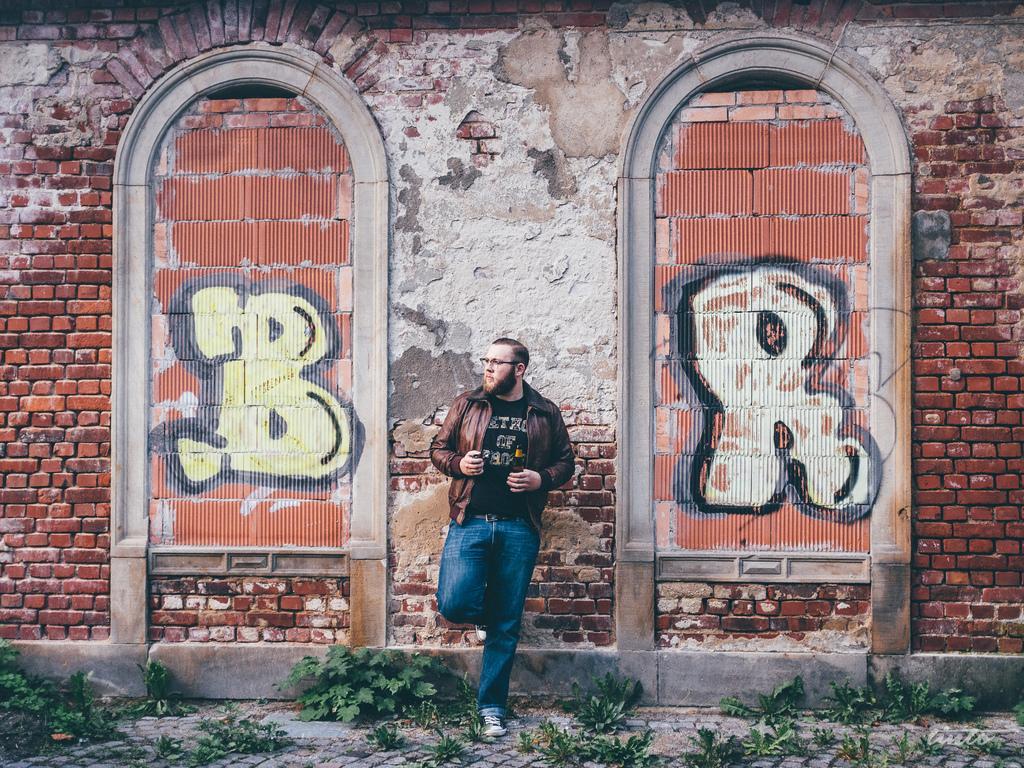Please provide a concise description of this image. In this image I can see the person standing and the person is wearing black, brown and blue color dress. In the background I can see the wall and the wall is in brown and white color, few plants in green color. 